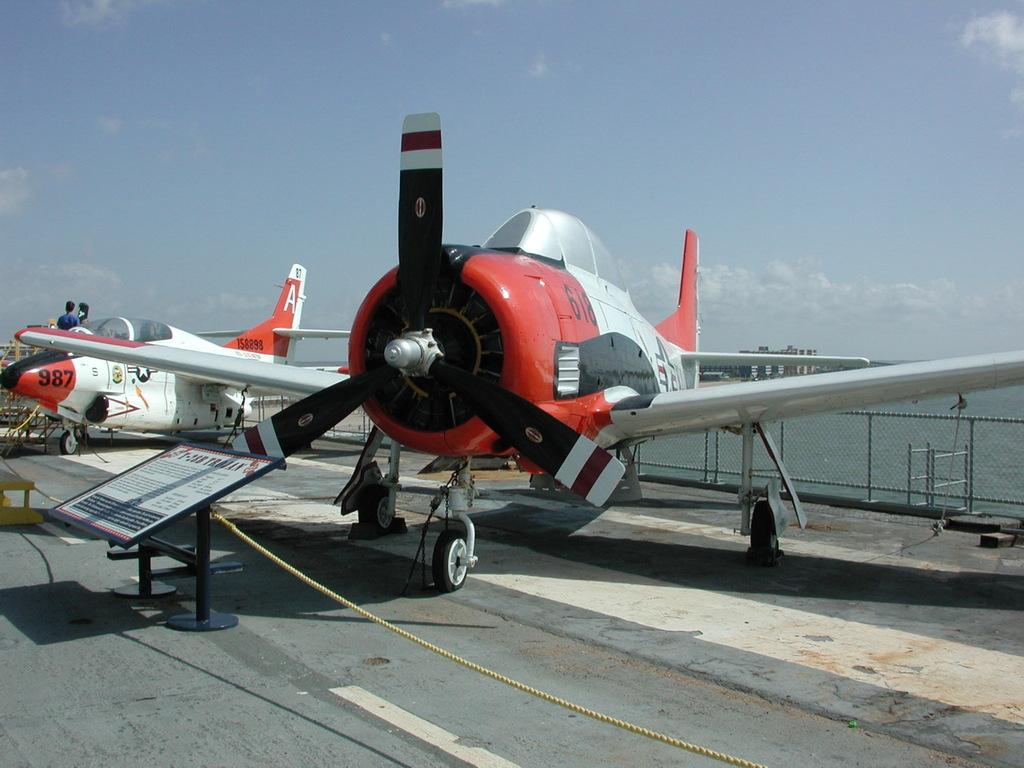<image>
Summarize the visual content of the image. An airplane with the numbers 618 written on the front 